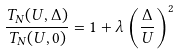<formula> <loc_0><loc_0><loc_500><loc_500>\frac { T _ { N } ( U , \Delta ) } { T _ { N } ( U , 0 ) } = 1 + \lambda \left ( \frac { \Delta } { U } \right ) ^ { 2 }</formula> 